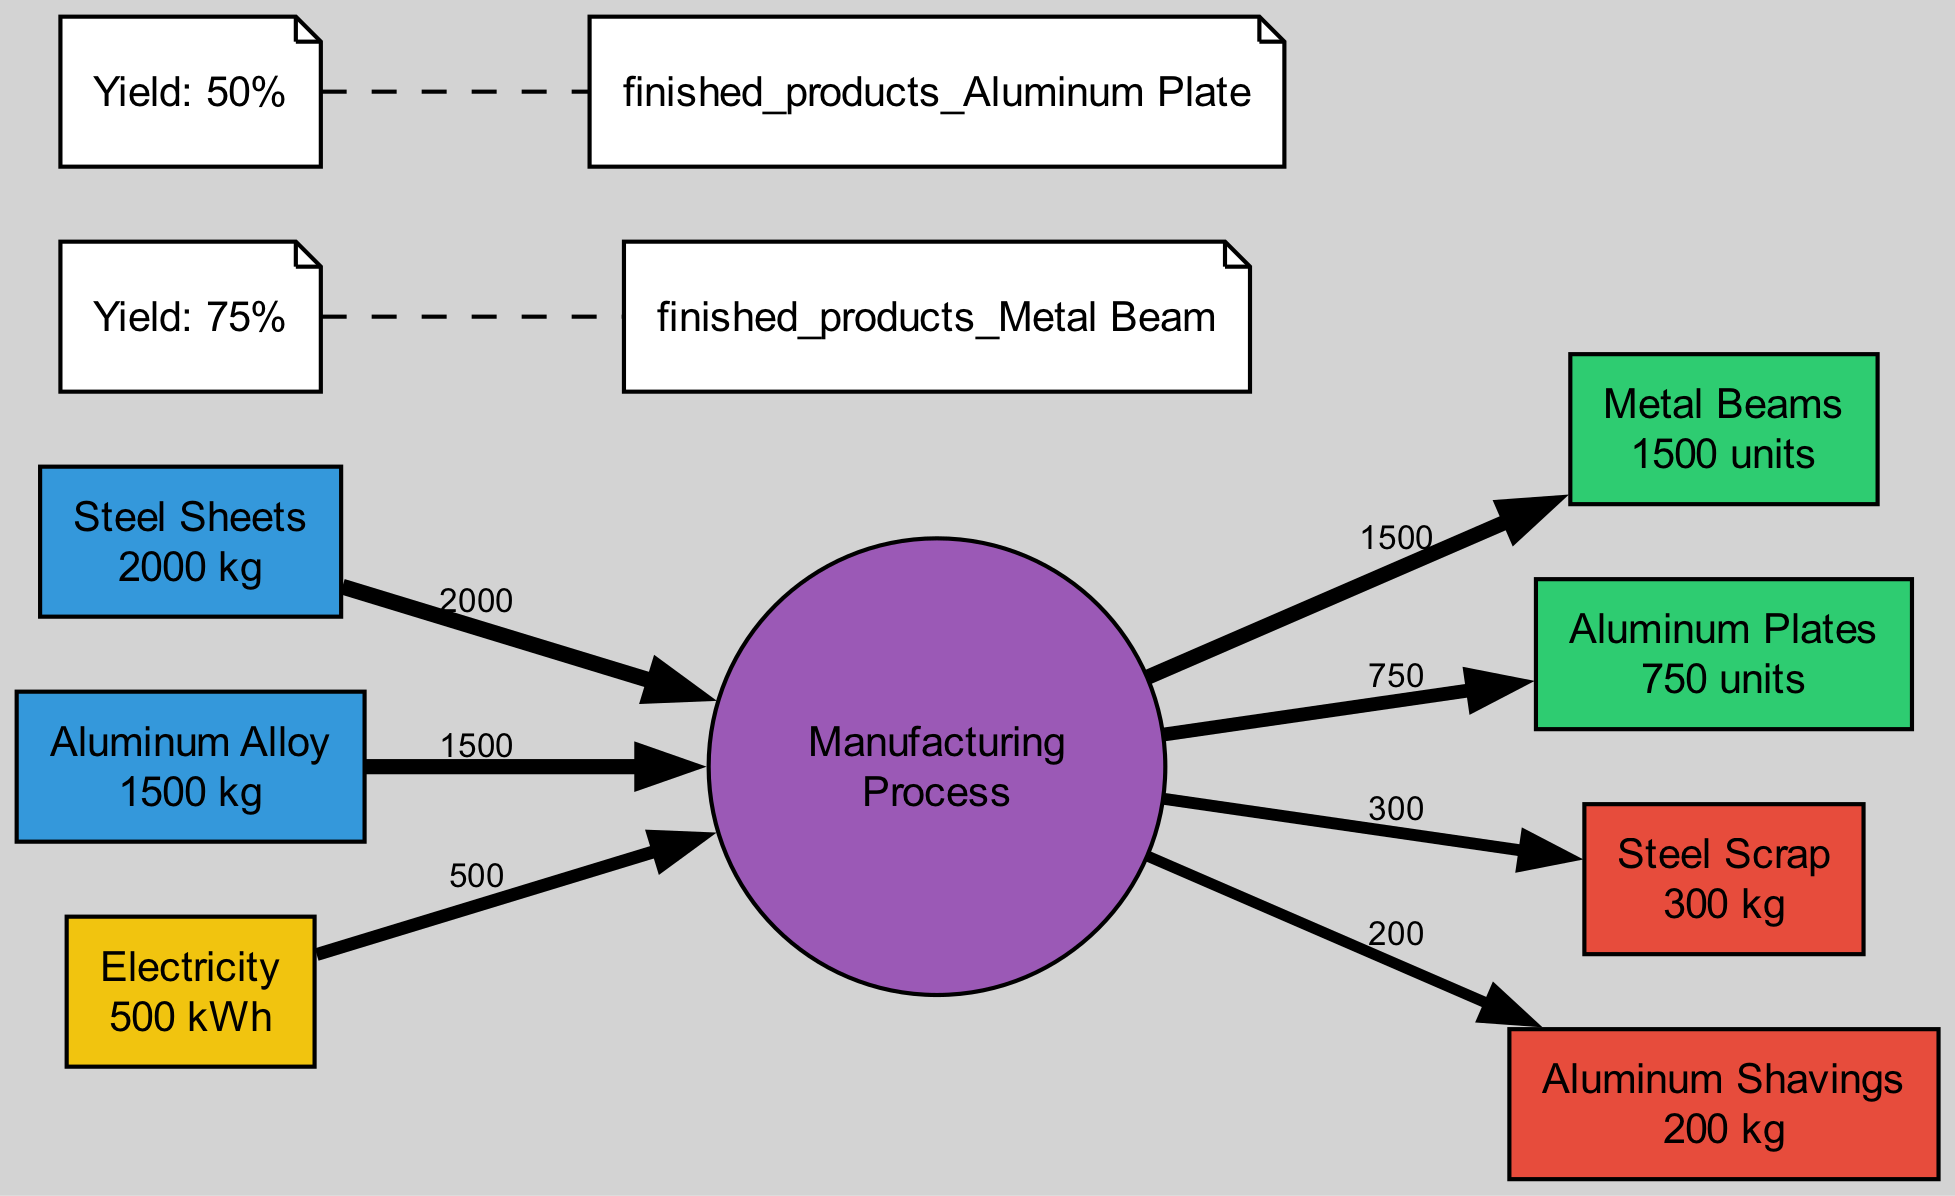What are the total input quantities for raw materials? The diagram indicates there are two types of raw materials: Steel Sheets (2000 kg) and Aluminum Alloy (1500 kg). By adding these amounts together, the total input quantity is 2000 kg + 1500 kg = 3500 kg.
Answer: 3500 kg How many finished products are produced? The diagram shows two categories of finished products: Metal Beams (1500 units) and Aluminum Plates (750 units). The total count of finished products is found by summing these units: 1500 + 750 = 2250 units.
Answer: 2250 units What type of waste is generated? The waste outputs from the manufacturing process include Steel Scrap and Aluminum Shavings, as specified in the diagram.
Answer: Steel Scrap, Aluminum Shavings What is the yield percentage for Metal Beams? According to the yield information presented in the diagram, the yield rate up for Metal Beams is explicitly stated as 75%.
Answer: 75% How is the yield of Aluminum Plates interpreted from the diagram? The diagram provides clarity on the yield of Aluminum Plates, which is noted to be 50%. This directly indicates that out of the total Aluminum processed, 50% successfully results in product form.
Answer: 50% What does the edge width indicate in the diagram? In the Sankey Diagram, edge width signifies the magnitude of flow for that particular material or product. For example, greater widths correspond to higher quantities, visually representing the input-output relationship.
Answer: Flow magnitude How does the quantity of Steel Scrap compare to the total input of Steel Sheets? The diagram indicates that Steel Scrap is 300 kg while the total input of Steel Sheets is 2000 kg. When comparing these quantities, Steel Scrap is a portion of the input and specifically represents 15% of the total Steel Sheets input quantity.
Answer: 15% Which input category has the highest quantity? By examining the input categories, Steel Sheets contribute 2000 kg while Aluminum Alloy provides 1500 kg. Steel Sheets clearly stands out as the input with the highest quantity.
Answer: Steel Sheets What is the net product from the inputs based on the yields? The yields indicate that for Metal Beams, 75% yield is achieved from some input Steel, and for Aluminum Plates, there is a 50% yield from the Aluminum input. This means that the outputs are generated based on the specified yields relative to their respective inputs.
Answer: Reflects yield-based outputs What visual cues indicate the production efficiency in the diagram? The Sankey Diagram utilizes the width of the edges to represent input and output quantities, alongside yield annotations. Greater input widths with comparatively smaller waste outputs suggest high production efficiency, evidenced by the yields of 75% and 50%.
Answer: Edge widths and yield annotations 